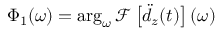<formula> <loc_0><loc_0><loc_500><loc_500>\Phi _ { 1 } ( \omega ) = \arg _ { \omega } \mathcal { F } \left [ \ddot { d } _ { z } ( t ) \right ] ( \omega )</formula> 